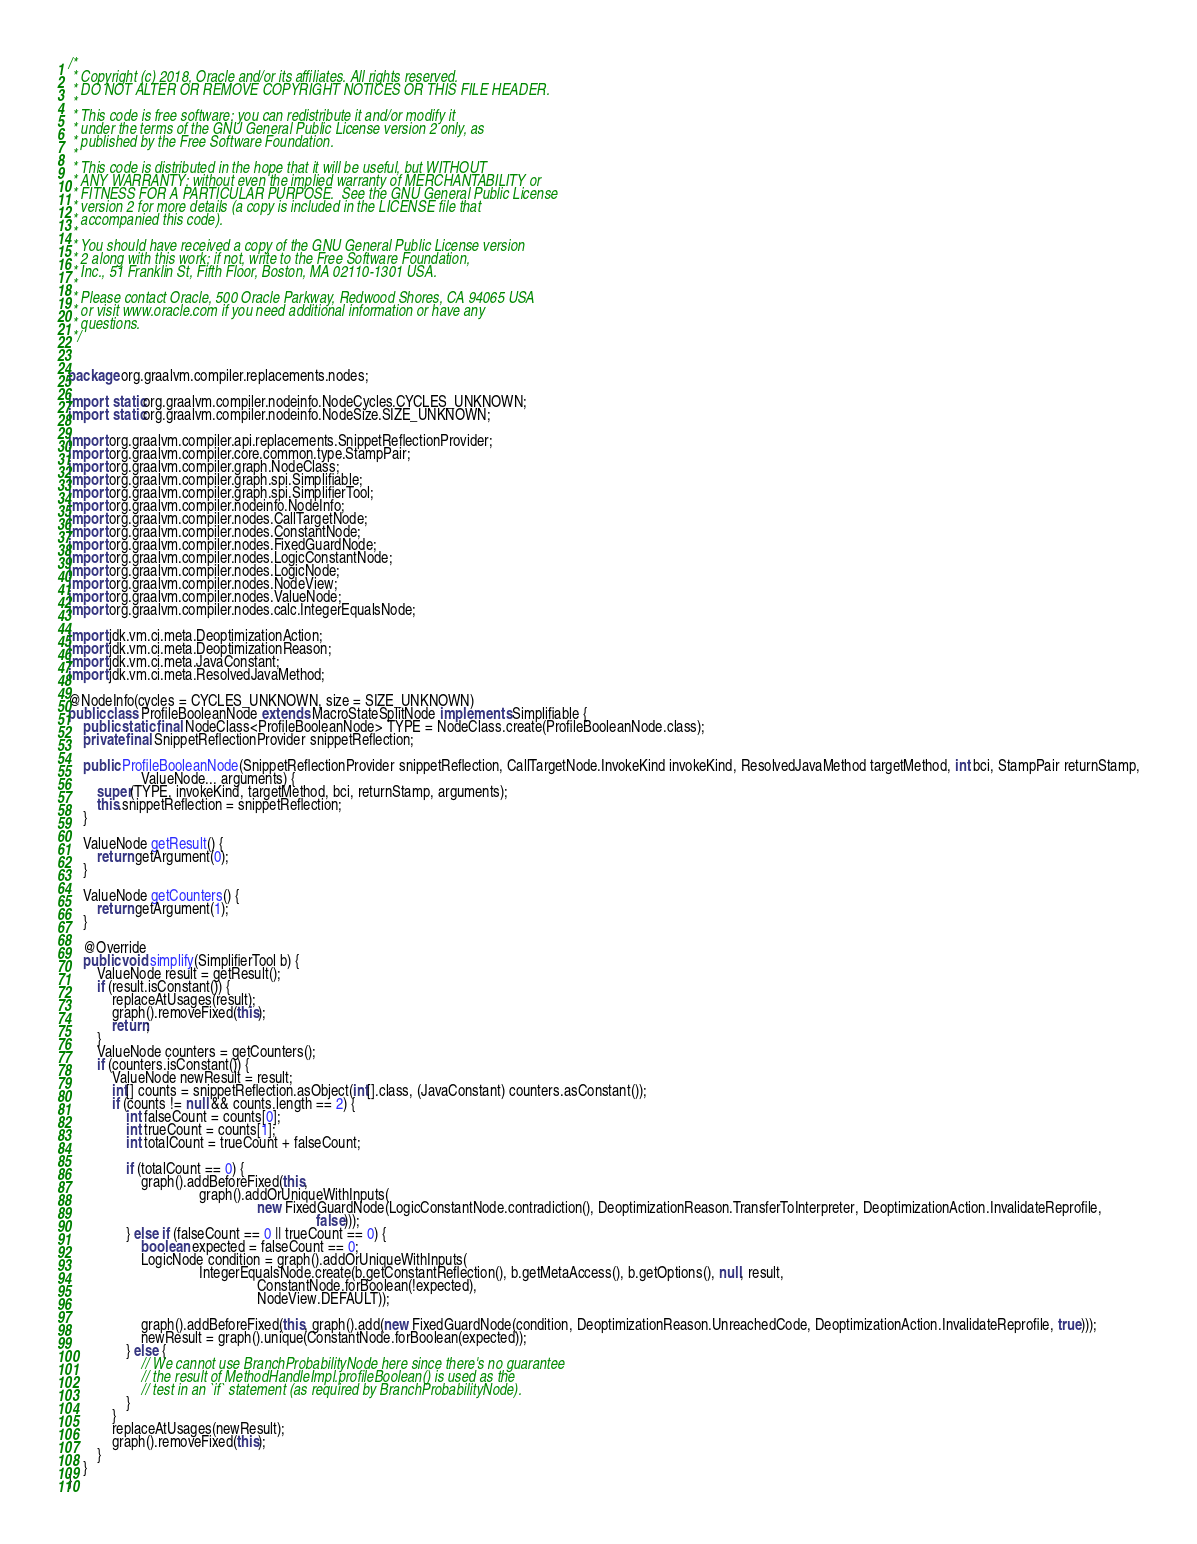Convert code to text. <code><loc_0><loc_0><loc_500><loc_500><_Java_>/*
 * Copyright (c) 2018, Oracle and/or its affiliates. All rights reserved.
 * DO NOT ALTER OR REMOVE COPYRIGHT NOTICES OR THIS FILE HEADER.
 *
 * This code is free software; you can redistribute it and/or modify it
 * under the terms of the GNU General Public License version 2 only, as
 * published by the Free Software Foundation.
 *
 * This code is distributed in the hope that it will be useful, but WITHOUT
 * ANY WARRANTY; without even the implied warranty of MERCHANTABILITY or
 * FITNESS FOR A PARTICULAR PURPOSE.  See the GNU General Public License
 * version 2 for more details (a copy is included in the LICENSE file that
 * accompanied this code).
 *
 * You should have received a copy of the GNU General Public License version
 * 2 along with this work; if not, write to the Free Software Foundation,
 * Inc., 51 Franklin St, Fifth Floor, Boston, MA 02110-1301 USA.
 *
 * Please contact Oracle, 500 Oracle Parkway, Redwood Shores, CA 94065 USA
 * or visit www.oracle.com if you need additional information or have any
 * questions.
 */


package org.graalvm.compiler.replacements.nodes;

import static org.graalvm.compiler.nodeinfo.NodeCycles.CYCLES_UNKNOWN;
import static org.graalvm.compiler.nodeinfo.NodeSize.SIZE_UNKNOWN;

import org.graalvm.compiler.api.replacements.SnippetReflectionProvider;
import org.graalvm.compiler.core.common.type.StampPair;
import org.graalvm.compiler.graph.NodeClass;
import org.graalvm.compiler.graph.spi.Simplifiable;
import org.graalvm.compiler.graph.spi.SimplifierTool;
import org.graalvm.compiler.nodeinfo.NodeInfo;
import org.graalvm.compiler.nodes.CallTargetNode;
import org.graalvm.compiler.nodes.ConstantNode;
import org.graalvm.compiler.nodes.FixedGuardNode;
import org.graalvm.compiler.nodes.LogicConstantNode;
import org.graalvm.compiler.nodes.LogicNode;
import org.graalvm.compiler.nodes.NodeView;
import org.graalvm.compiler.nodes.ValueNode;
import org.graalvm.compiler.nodes.calc.IntegerEqualsNode;

import jdk.vm.ci.meta.DeoptimizationAction;
import jdk.vm.ci.meta.DeoptimizationReason;
import jdk.vm.ci.meta.JavaConstant;
import jdk.vm.ci.meta.ResolvedJavaMethod;

@NodeInfo(cycles = CYCLES_UNKNOWN, size = SIZE_UNKNOWN)
public class ProfileBooleanNode extends MacroStateSplitNode implements Simplifiable {
    public static final NodeClass<ProfileBooleanNode> TYPE = NodeClass.create(ProfileBooleanNode.class);
    private final SnippetReflectionProvider snippetReflection;

    public ProfileBooleanNode(SnippetReflectionProvider snippetReflection, CallTargetNode.InvokeKind invokeKind, ResolvedJavaMethod targetMethod, int bci, StampPair returnStamp,
                    ValueNode... arguments) {
        super(TYPE, invokeKind, targetMethod, bci, returnStamp, arguments);
        this.snippetReflection = snippetReflection;
    }

    ValueNode getResult() {
        return getArgument(0);
    }

    ValueNode getCounters() {
        return getArgument(1);
    }

    @Override
    public void simplify(SimplifierTool b) {
        ValueNode result = getResult();
        if (result.isConstant()) {
            replaceAtUsages(result);
            graph().removeFixed(this);
            return;
        }
        ValueNode counters = getCounters();
        if (counters.isConstant()) {
            ValueNode newResult = result;
            int[] counts = snippetReflection.asObject(int[].class, (JavaConstant) counters.asConstant());
            if (counts != null && counts.length == 2) {
                int falseCount = counts[0];
                int trueCount = counts[1];
                int totalCount = trueCount + falseCount;

                if (totalCount == 0) {
                    graph().addBeforeFixed(this,
                                    graph().addOrUniqueWithInputs(
                                                    new FixedGuardNode(LogicConstantNode.contradiction(), DeoptimizationReason.TransferToInterpreter, DeoptimizationAction.InvalidateReprofile,
                                                                    false)));
                } else if (falseCount == 0 || trueCount == 0) {
                    boolean expected = falseCount == 0;
                    LogicNode condition = graph().addOrUniqueWithInputs(
                                    IntegerEqualsNode.create(b.getConstantReflection(), b.getMetaAccess(), b.getOptions(), null, result,
                                                    ConstantNode.forBoolean(!expected),
                                                    NodeView.DEFAULT));

                    graph().addBeforeFixed(this, graph().add(new FixedGuardNode(condition, DeoptimizationReason.UnreachedCode, DeoptimizationAction.InvalidateReprofile, true)));
                    newResult = graph().unique(ConstantNode.forBoolean(expected));
                } else {
                    // We cannot use BranchProbabilityNode here since there's no guarantee
                    // the result of MethodHandleImpl.profileBoolean() is used as the
                    // test in an `if` statement (as required by BranchProbabilityNode).
                }
            }
            replaceAtUsages(newResult);
            graph().removeFixed(this);
        }
    }
}
</code> 